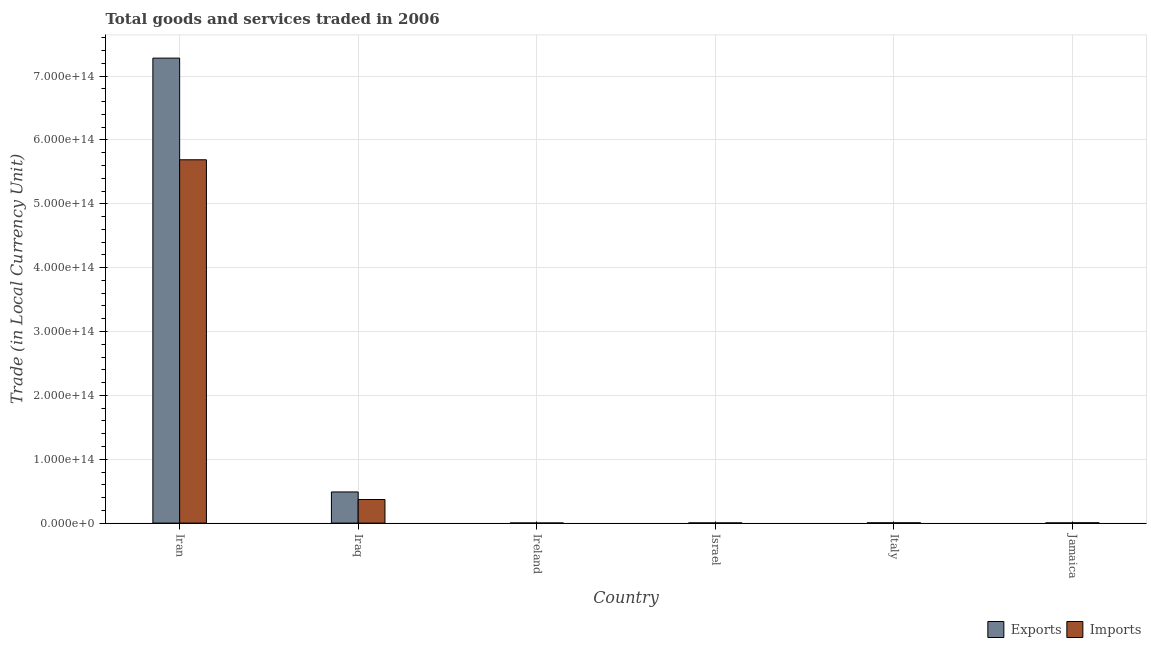How many different coloured bars are there?
Ensure brevity in your answer.  2. What is the label of the 2nd group of bars from the left?
Provide a succinct answer. Iraq. In how many cases, is the number of bars for a given country not equal to the number of legend labels?
Ensure brevity in your answer.  0. What is the imports of goods and services in Jamaica?
Make the answer very short. 4.75e+11. Across all countries, what is the maximum export of goods and services?
Offer a terse response. 7.28e+14. Across all countries, what is the minimum imports of goods and services?
Offer a terse response. 1.31e+11. In which country was the imports of goods and services maximum?
Offer a very short reply. Iran. In which country was the imports of goods and services minimum?
Provide a short and direct response. Ireland. What is the total imports of goods and services in the graph?
Your response must be concise. 6.07e+14. What is the difference between the export of goods and services in Iran and that in Israel?
Make the answer very short. 7.28e+14. What is the difference between the imports of goods and services in Iran and the export of goods and services in Iraq?
Give a very brief answer. 5.20e+14. What is the average imports of goods and services per country?
Your answer should be very brief. 1.01e+14. What is the difference between the export of goods and services and imports of goods and services in Israel?
Your response must be concise. 2.56e+09. In how many countries, is the export of goods and services greater than 180000000000000 LCU?
Give a very brief answer. 1. What is the ratio of the imports of goods and services in Iraq to that in Ireland?
Offer a terse response. 281.22. Is the imports of goods and services in Iraq less than that in Ireland?
Offer a terse response. No. Is the difference between the imports of goods and services in Italy and Jamaica greater than the difference between the export of goods and services in Italy and Jamaica?
Make the answer very short. No. What is the difference between the highest and the second highest export of goods and services?
Provide a succinct answer. 6.79e+14. What is the difference between the highest and the lowest export of goods and services?
Your response must be concise. 7.28e+14. In how many countries, is the imports of goods and services greater than the average imports of goods and services taken over all countries?
Offer a terse response. 1. What does the 2nd bar from the left in Italy represents?
Offer a terse response. Imports. What does the 1st bar from the right in Iran represents?
Provide a short and direct response. Imports. What is the difference between two consecutive major ticks on the Y-axis?
Ensure brevity in your answer.  1.00e+14. Are the values on the major ticks of Y-axis written in scientific E-notation?
Your answer should be compact. Yes. Where does the legend appear in the graph?
Ensure brevity in your answer.  Bottom right. What is the title of the graph?
Ensure brevity in your answer.  Total goods and services traded in 2006. Does "National Tourists" appear as one of the legend labels in the graph?
Ensure brevity in your answer.  No. What is the label or title of the Y-axis?
Keep it short and to the point. Trade (in Local Currency Unit). What is the Trade (in Local Currency Unit) of Exports in Iran?
Offer a terse response. 7.28e+14. What is the Trade (in Local Currency Unit) in Imports in Iran?
Your answer should be compact. 5.69e+14. What is the Trade (in Local Currency Unit) in Exports in Iraq?
Provide a short and direct response. 4.88e+13. What is the Trade (in Local Currency Unit) in Imports in Iraq?
Provide a short and direct response. 3.69e+13. What is the Trade (in Local Currency Unit) of Exports in Ireland?
Offer a very short reply. 1.46e+11. What is the Trade (in Local Currency Unit) of Imports in Ireland?
Make the answer very short. 1.31e+11. What is the Trade (in Local Currency Unit) of Exports in Israel?
Offer a terse response. 2.80e+11. What is the Trade (in Local Currency Unit) of Imports in Israel?
Provide a short and direct response. 2.78e+11. What is the Trade (in Local Currency Unit) in Exports in Italy?
Offer a very short reply. 4.06e+11. What is the Trade (in Local Currency Unit) of Imports in Italy?
Your answer should be compact. 4.19e+11. What is the Trade (in Local Currency Unit) of Exports in Jamaica?
Your answer should be very brief. 3.15e+11. What is the Trade (in Local Currency Unit) in Imports in Jamaica?
Ensure brevity in your answer.  4.75e+11. Across all countries, what is the maximum Trade (in Local Currency Unit) of Exports?
Offer a very short reply. 7.28e+14. Across all countries, what is the maximum Trade (in Local Currency Unit) in Imports?
Offer a terse response. 5.69e+14. Across all countries, what is the minimum Trade (in Local Currency Unit) in Exports?
Ensure brevity in your answer.  1.46e+11. Across all countries, what is the minimum Trade (in Local Currency Unit) of Imports?
Offer a very short reply. 1.31e+11. What is the total Trade (in Local Currency Unit) in Exports in the graph?
Offer a terse response. 7.78e+14. What is the total Trade (in Local Currency Unit) in Imports in the graph?
Keep it short and to the point. 6.07e+14. What is the difference between the Trade (in Local Currency Unit) in Exports in Iran and that in Iraq?
Your answer should be compact. 6.79e+14. What is the difference between the Trade (in Local Currency Unit) in Imports in Iran and that in Iraq?
Your answer should be compact. 5.32e+14. What is the difference between the Trade (in Local Currency Unit) in Exports in Iran and that in Ireland?
Provide a succinct answer. 7.28e+14. What is the difference between the Trade (in Local Currency Unit) in Imports in Iran and that in Ireland?
Keep it short and to the point. 5.69e+14. What is the difference between the Trade (in Local Currency Unit) of Exports in Iran and that in Israel?
Your response must be concise. 7.28e+14. What is the difference between the Trade (in Local Currency Unit) of Imports in Iran and that in Israel?
Ensure brevity in your answer.  5.69e+14. What is the difference between the Trade (in Local Currency Unit) in Exports in Iran and that in Italy?
Provide a short and direct response. 7.28e+14. What is the difference between the Trade (in Local Currency Unit) of Imports in Iran and that in Italy?
Give a very brief answer. 5.69e+14. What is the difference between the Trade (in Local Currency Unit) in Exports in Iran and that in Jamaica?
Provide a succinct answer. 7.28e+14. What is the difference between the Trade (in Local Currency Unit) in Imports in Iran and that in Jamaica?
Keep it short and to the point. 5.69e+14. What is the difference between the Trade (in Local Currency Unit) of Exports in Iraq and that in Ireland?
Your answer should be compact. 4.86e+13. What is the difference between the Trade (in Local Currency Unit) in Imports in Iraq and that in Ireland?
Your response must be concise. 3.68e+13. What is the difference between the Trade (in Local Currency Unit) of Exports in Iraq and that in Israel?
Your answer should be very brief. 4.85e+13. What is the difference between the Trade (in Local Currency Unit) in Imports in Iraq and that in Israel?
Offer a very short reply. 3.66e+13. What is the difference between the Trade (in Local Currency Unit) in Exports in Iraq and that in Italy?
Your response must be concise. 4.84e+13. What is the difference between the Trade (in Local Currency Unit) of Imports in Iraq and that in Italy?
Offer a very short reply. 3.65e+13. What is the difference between the Trade (in Local Currency Unit) of Exports in Iraq and that in Jamaica?
Your answer should be compact. 4.85e+13. What is the difference between the Trade (in Local Currency Unit) of Imports in Iraq and that in Jamaica?
Ensure brevity in your answer.  3.64e+13. What is the difference between the Trade (in Local Currency Unit) of Exports in Ireland and that in Israel?
Keep it short and to the point. -1.34e+11. What is the difference between the Trade (in Local Currency Unit) in Imports in Ireland and that in Israel?
Offer a very short reply. -1.47e+11. What is the difference between the Trade (in Local Currency Unit) in Exports in Ireland and that in Italy?
Keep it short and to the point. -2.60e+11. What is the difference between the Trade (in Local Currency Unit) in Imports in Ireland and that in Italy?
Provide a succinct answer. -2.88e+11. What is the difference between the Trade (in Local Currency Unit) of Exports in Ireland and that in Jamaica?
Give a very brief answer. -1.69e+11. What is the difference between the Trade (in Local Currency Unit) in Imports in Ireland and that in Jamaica?
Ensure brevity in your answer.  -3.44e+11. What is the difference between the Trade (in Local Currency Unit) of Exports in Israel and that in Italy?
Your response must be concise. -1.26e+11. What is the difference between the Trade (in Local Currency Unit) in Imports in Israel and that in Italy?
Offer a terse response. -1.41e+11. What is the difference between the Trade (in Local Currency Unit) in Exports in Israel and that in Jamaica?
Offer a terse response. -3.43e+1. What is the difference between the Trade (in Local Currency Unit) of Imports in Israel and that in Jamaica?
Your answer should be compact. -1.97e+11. What is the difference between the Trade (in Local Currency Unit) of Exports in Italy and that in Jamaica?
Make the answer very short. 9.14e+1. What is the difference between the Trade (in Local Currency Unit) in Imports in Italy and that in Jamaica?
Give a very brief answer. -5.63e+1. What is the difference between the Trade (in Local Currency Unit) of Exports in Iran and the Trade (in Local Currency Unit) of Imports in Iraq?
Your response must be concise. 6.91e+14. What is the difference between the Trade (in Local Currency Unit) in Exports in Iran and the Trade (in Local Currency Unit) in Imports in Ireland?
Make the answer very short. 7.28e+14. What is the difference between the Trade (in Local Currency Unit) in Exports in Iran and the Trade (in Local Currency Unit) in Imports in Israel?
Your answer should be very brief. 7.28e+14. What is the difference between the Trade (in Local Currency Unit) of Exports in Iran and the Trade (in Local Currency Unit) of Imports in Italy?
Your answer should be very brief. 7.28e+14. What is the difference between the Trade (in Local Currency Unit) of Exports in Iran and the Trade (in Local Currency Unit) of Imports in Jamaica?
Your response must be concise. 7.28e+14. What is the difference between the Trade (in Local Currency Unit) of Exports in Iraq and the Trade (in Local Currency Unit) of Imports in Ireland?
Provide a short and direct response. 4.86e+13. What is the difference between the Trade (in Local Currency Unit) of Exports in Iraq and the Trade (in Local Currency Unit) of Imports in Israel?
Ensure brevity in your answer.  4.85e+13. What is the difference between the Trade (in Local Currency Unit) of Exports in Iraq and the Trade (in Local Currency Unit) of Imports in Italy?
Offer a very short reply. 4.84e+13. What is the difference between the Trade (in Local Currency Unit) in Exports in Iraq and the Trade (in Local Currency Unit) in Imports in Jamaica?
Keep it short and to the point. 4.83e+13. What is the difference between the Trade (in Local Currency Unit) in Exports in Ireland and the Trade (in Local Currency Unit) in Imports in Israel?
Your answer should be compact. -1.32e+11. What is the difference between the Trade (in Local Currency Unit) in Exports in Ireland and the Trade (in Local Currency Unit) in Imports in Italy?
Give a very brief answer. -2.73e+11. What is the difference between the Trade (in Local Currency Unit) of Exports in Ireland and the Trade (in Local Currency Unit) of Imports in Jamaica?
Ensure brevity in your answer.  -3.29e+11. What is the difference between the Trade (in Local Currency Unit) of Exports in Israel and the Trade (in Local Currency Unit) of Imports in Italy?
Your answer should be compact. -1.39e+11. What is the difference between the Trade (in Local Currency Unit) in Exports in Israel and the Trade (in Local Currency Unit) in Imports in Jamaica?
Ensure brevity in your answer.  -1.95e+11. What is the difference between the Trade (in Local Currency Unit) of Exports in Italy and the Trade (in Local Currency Unit) of Imports in Jamaica?
Offer a terse response. -6.93e+1. What is the average Trade (in Local Currency Unit) in Exports per country?
Provide a succinct answer. 1.30e+14. What is the average Trade (in Local Currency Unit) in Imports per country?
Make the answer very short. 1.01e+14. What is the difference between the Trade (in Local Currency Unit) of Exports and Trade (in Local Currency Unit) of Imports in Iran?
Your response must be concise. 1.59e+14. What is the difference between the Trade (in Local Currency Unit) of Exports and Trade (in Local Currency Unit) of Imports in Iraq?
Your answer should be very brief. 1.19e+13. What is the difference between the Trade (in Local Currency Unit) of Exports and Trade (in Local Currency Unit) of Imports in Ireland?
Provide a short and direct response. 1.49e+1. What is the difference between the Trade (in Local Currency Unit) in Exports and Trade (in Local Currency Unit) in Imports in Israel?
Offer a terse response. 2.56e+09. What is the difference between the Trade (in Local Currency Unit) in Exports and Trade (in Local Currency Unit) in Imports in Italy?
Your answer should be very brief. -1.30e+1. What is the difference between the Trade (in Local Currency Unit) of Exports and Trade (in Local Currency Unit) of Imports in Jamaica?
Make the answer very short. -1.61e+11. What is the ratio of the Trade (in Local Currency Unit) in Exports in Iran to that in Iraq?
Make the answer very short. 14.93. What is the ratio of the Trade (in Local Currency Unit) of Imports in Iran to that in Iraq?
Keep it short and to the point. 15.41. What is the ratio of the Trade (in Local Currency Unit) in Exports in Iran to that in Ireland?
Provide a short and direct response. 4982.57. What is the ratio of the Trade (in Local Currency Unit) in Imports in Iran to that in Ireland?
Your response must be concise. 4334.69. What is the ratio of the Trade (in Local Currency Unit) of Exports in Iran to that in Israel?
Ensure brevity in your answer.  2596.07. What is the ratio of the Trade (in Local Currency Unit) in Imports in Iran to that in Israel?
Keep it short and to the point. 2047.21. What is the ratio of the Trade (in Local Currency Unit) of Exports in Iran to that in Italy?
Give a very brief answer. 1793. What is the ratio of the Trade (in Local Currency Unit) of Imports in Iran to that in Italy?
Keep it short and to the point. 1357.71. What is the ratio of the Trade (in Local Currency Unit) of Exports in Iran to that in Jamaica?
Your response must be concise. 2313.46. What is the ratio of the Trade (in Local Currency Unit) in Imports in Iran to that in Jamaica?
Make the answer very short. 1196.83. What is the ratio of the Trade (in Local Currency Unit) of Exports in Iraq to that in Ireland?
Your response must be concise. 333.77. What is the ratio of the Trade (in Local Currency Unit) in Imports in Iraq to that in Ireland?
Give a very brief answer. 281.22. What is the ratio of the Trade (in Local Currency Unit) in Exports in Iraq to that in Israel?
Keep it short and to the point. 173.91. What is the ratio of the Trade (in Local Currency Unit) of Imports in Iraq to that in Israel?
Offer a terse response. 132.82. What is the ratio of the Trade (in Local Currency Unit) in Exports in Iraq to that in Italy?
Provide a short and direct response. 120.11. What is the ratio of the Trade (in Local Currency Unit) in Imports in Iraq to that in Italy?
Your answer should be very brief. 88.08. What is the ratio of the Trade (in Local Currency Unit) of Exports in Iraq to that in Jamaica?
Keep it short and to the point. 154.97. What is the ratio of the Trade (in Local Currency Unit) of Imports in Iraq to that in Jamaica?
Ensure brevity in your answer.  77.65. What is the ratio of the Trade (in Local Currency Unit) of Exports in Ireland to that in Israel?
Provide a short and direct response. 0.52. What is the ratio of the Trade (in Local Currency Unit) of Imports in Ireland to that in Israel?
Keep it short and to the point. 0.47. What is the ratio of the Trade (in Local Currency Unit) in Exports in Ireland to that in Italy?
Your response must be concise. 0.36. What is the ratio of the Trade (in Local Currency Unit) in Imports in Ireland to that in Italy?
Your answer should be very brief. 0.31. What is the ratio of the Trade (in Local Currency Unit) in Exports in Ireland to that in Jamaica?
Provide a short and direct response. 0.46. What is the ratio of the Trade (in Local Currency Unit) in Imports in Ireland to that in Jamaica?
Provide a short and direct response. 0.28. What is the ratio of the Trade (in Local Currency Unit) in Exports in Israel to that in Italy?
Provide a succinct answer. 0.69. What is the ratio of the Trade (in Local Currency Unit) of Imports in Israel to that in Italy?
Ensure brevity in your answer.  0.66. What is the ratio of the Trade (in Local Currency Unit) in Exports in Israel to that in Jamaica?
Your answer should be compact. 0.89. What is the ratio of the Trade (in Local Currency Unit) in Imports in Israel to that in Jamaica?
Offer a very short reply. 0.58. What is the ratio of the Trade (in Local Currency Unit) in Exports in Italy to that in Jamaica?
Offer a very short reply. 1.29. What is the ratio of the Trade (in Local Currency Unit) of Imports in Italy to that in Jamaica?
Make the answer very short. 0.88. What is the difference between the highest and the second highest Trade (in Local Currency Unit) of Exports?
Provide a short and direct response. 6.79e+14. What is the difference between the highest and the second highest Trade (in Local Currency Unit) in Imports?
Your answer should be very brief. 5.32e+14. What is the difference between the highest and the lowest Trade (in Local Currency Unit) of Exports?
Ensure brevity in your answer.  7.28e+14. What is the difference between the highest and the lowest Trade (in Local Currency Unit) in Imports?
Make the answer very short. 5.69e+14. 